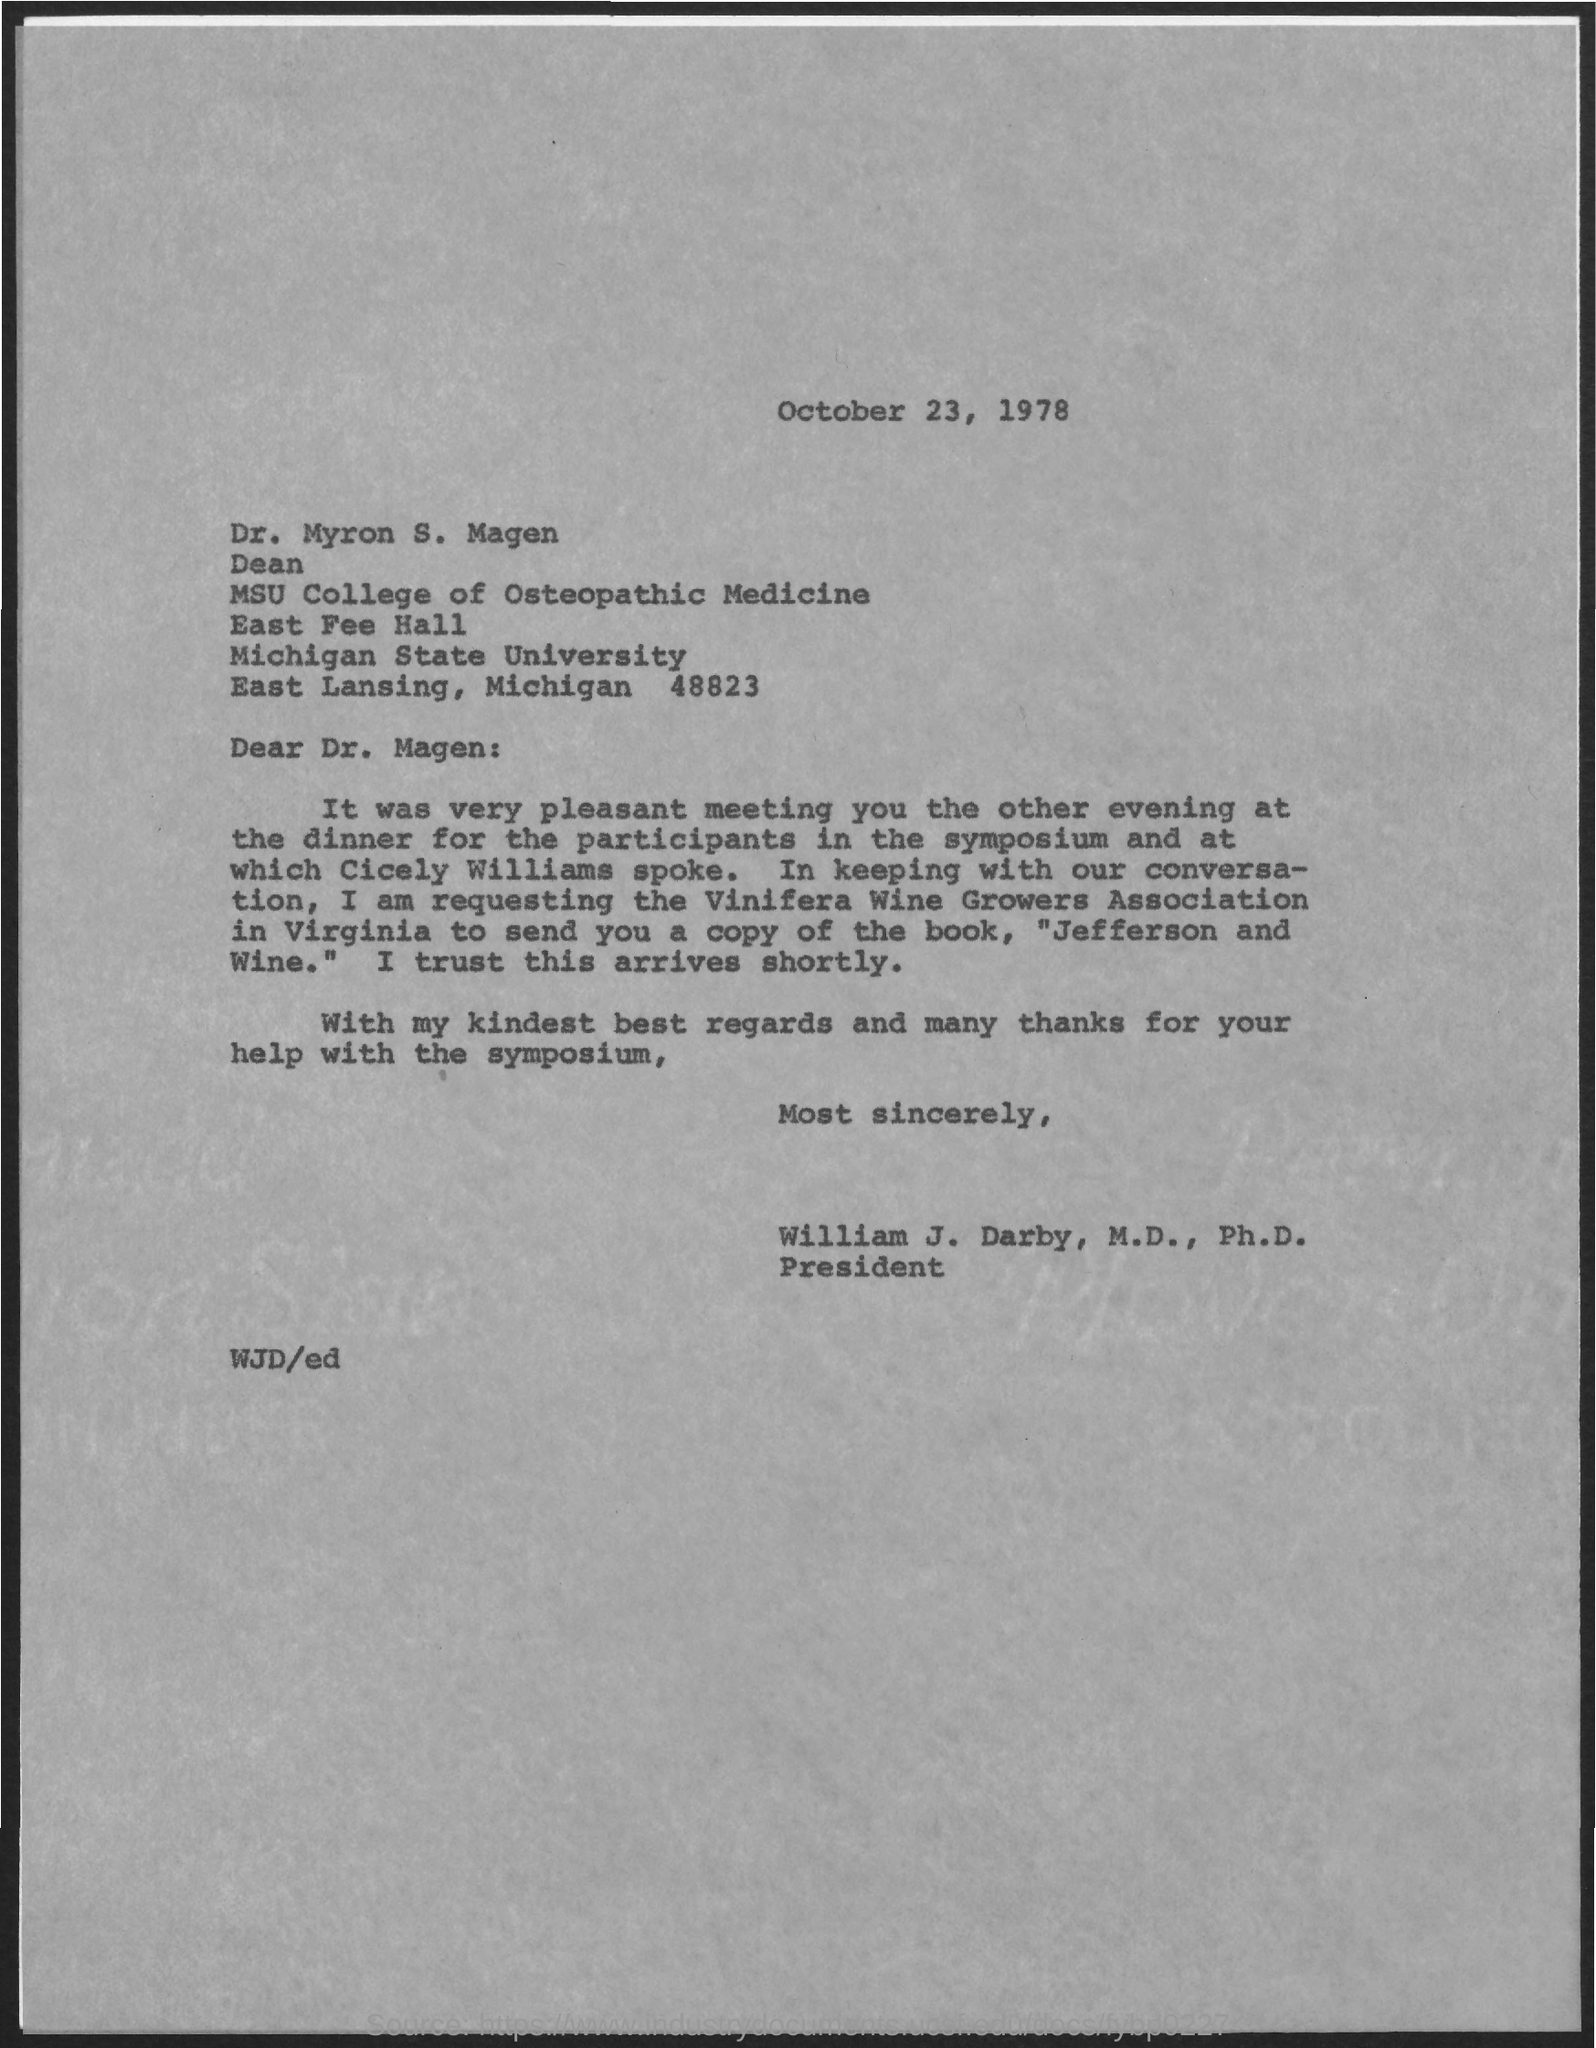What is the date mentioned in the given letter ?
Offer a very short reply. October 23, 1978. To whom this letter was written ?
Your answer should be compact. Dr. Magen. What is the designation of dr. myron s. magen ?
Your answer should be very brief. Dean. To which college dr. myron s. magen belongs to ?
Ensure brevity in your answer.  MSU college of Osteopathic medicine. What is the name of the university mentioned in the given letter ?
Give a very brief answer. Michigan State University. What is the designation of william  j. darby ?
Provide a succinct answer. President. 